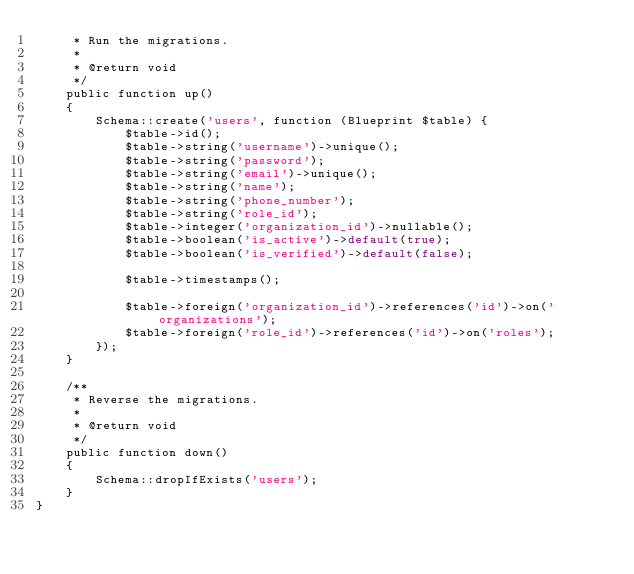<code> <loc_0><loc_0><loc_500><loc_500><_PHP_>     * Run the migrations.
     *
     * @return void
     */
    public function up()
    {
        Schema::create('users', function (Blueprint $table) {
            $table->id();
            $table->string('username')->unique();
            $table->string('password');
            $table->string('email')->unique();
            $table->string('name');
            $table->string('phone_number');
            $table->string('role_id');
            $table->integer('organization_id')->nullable();
            $table->boolean('is_active')->default(true);
            $table->boolean('is_verified')->default(false);

            $table->timestamps();

            $table->foreign('organization_id')->references('id')->on('organizations');
            $table->foreign('role_id')->references('id')->on('roles');
        });
    }

    /**
     * Reverse the migrations.
     *
     * @return void
     */
    public function down()
    {
        Schema::dropIfExists('users');
    }
}
</code> 